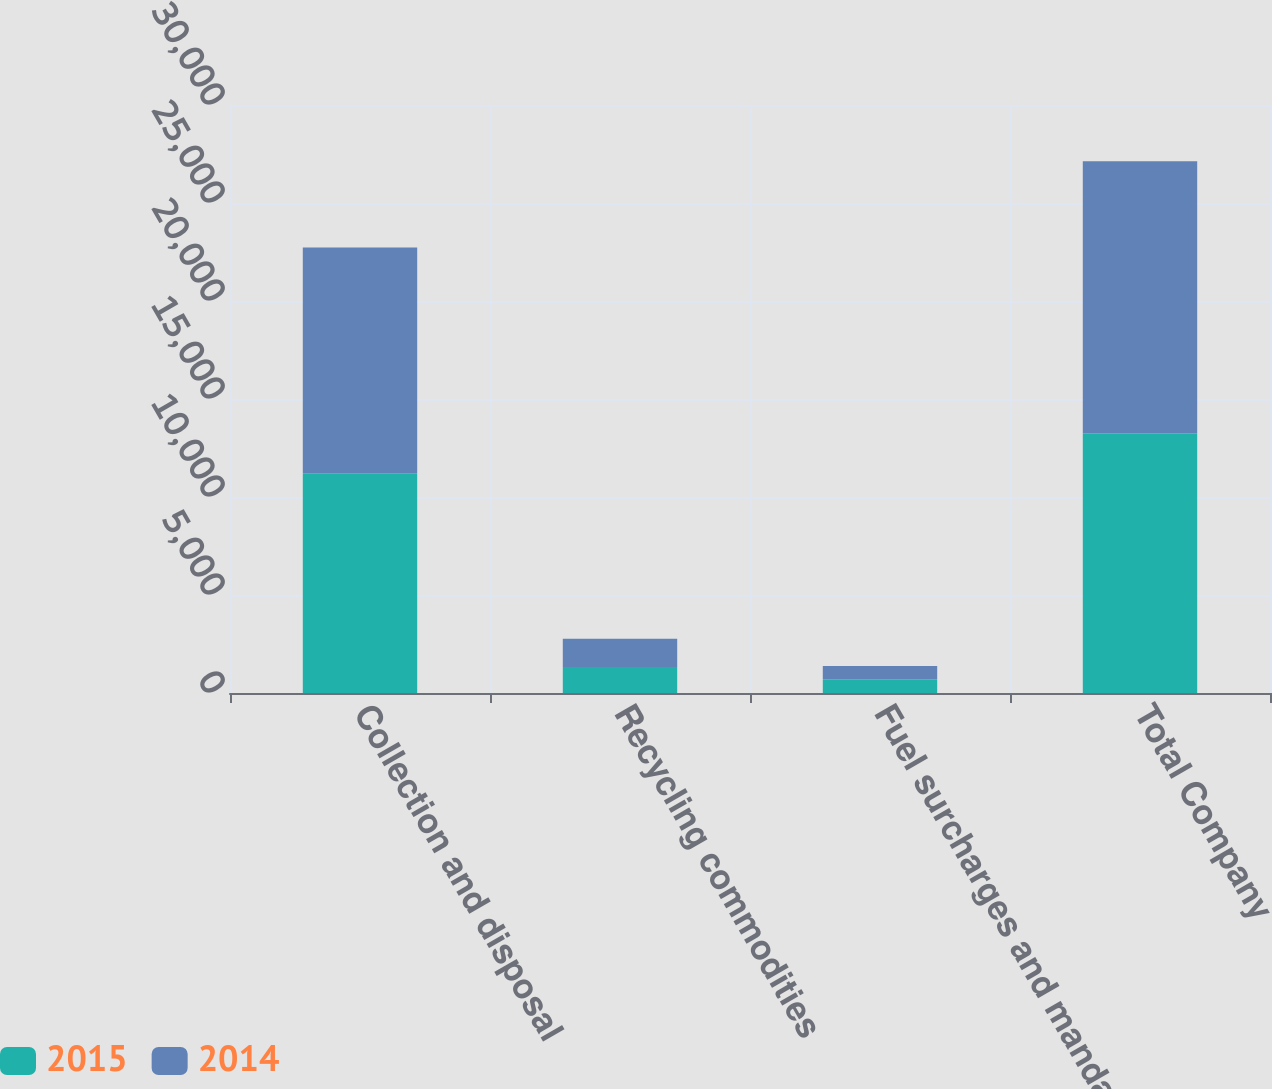Convert chart. <chart><loc_0><loc_0><loc_500><loc_500><stacked_bar_chart><ecel><fcel>Collection and disposal<fcel>Recycling commodities<fcel>Fuel surcharges and mandated<fcel>Total Company<nl><fcel>2015<fcel>11214<fcel>1331<fcel>689<fcel>13234<nl><fcel>2014<fcel>11512<fcel>1431<fcel>684<fcel>13893<nl></chart> 